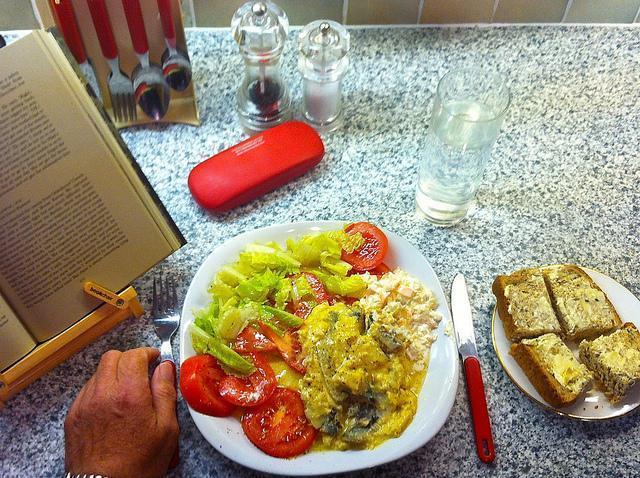Is the caption "The person is behind the dining table." a true representation of the image?
Answer yes or no. No. 